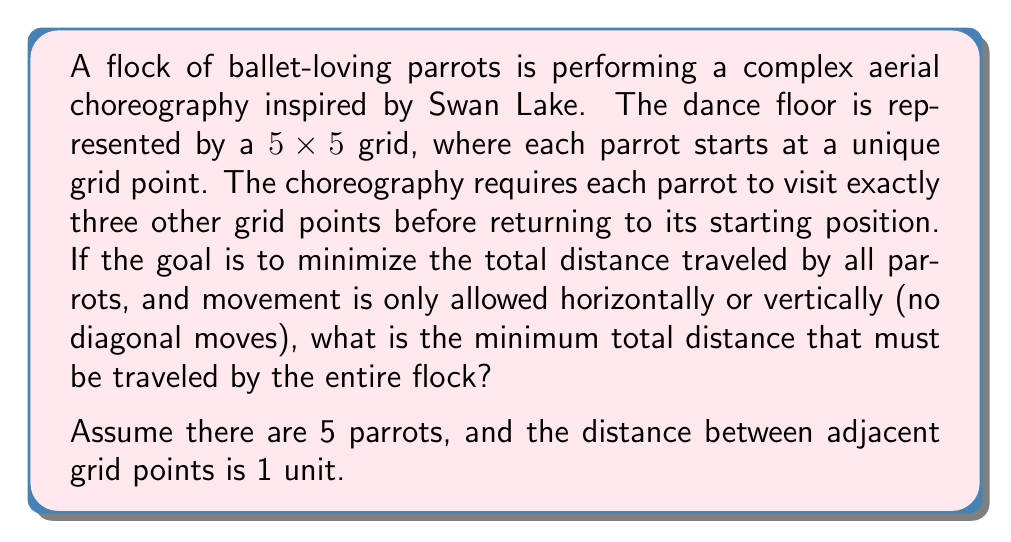Provide a solution to this math problem. To solve this optimization problem, we need to consider the following:

1) Each parrot must visit 3 other points and return to its starting position.
2) The minimum distance for each parrot to complete this requirement is 4 units.
3) The total minimum distance for all 5 parrots would be $5 * 4 = 20$ units.

Let's break it down step-by-step:

1) For a single parrot:
   - Minimum moves to visit 3 points: 3 units
   - Return to starting position: 1 unit
   - Total for one parrot: 3 + 1 = 4 units

2) Optimal path for each parrot:
   - Move 1 unit in any direction (up, down, left, or right)
   - Move 1 unit perpendicular to the first move
   - Move 1 unit parallel to the second move
   - Return 1 unit to the starting position

   This forms a square path, which is the most efficient way to visit 3 points and return.

3) Total for all parrots:
   $$\text{Total distance} = \text{Number of parrots} * \text{Distance per parrot}$$
   $$\text{Total distance} = 5 * 4 = 20 \text{ units}$$

This solution assumes that the parrots' paths don't need to be unique or non-overlapping, as the question doesn't specify this constraint. If paths needed to be unique, the problem would be more complex and likely result in a larger total distance.
Answer: The minimum total distance that must be traveled by the entire flock of 5 parrots is 20 units. 